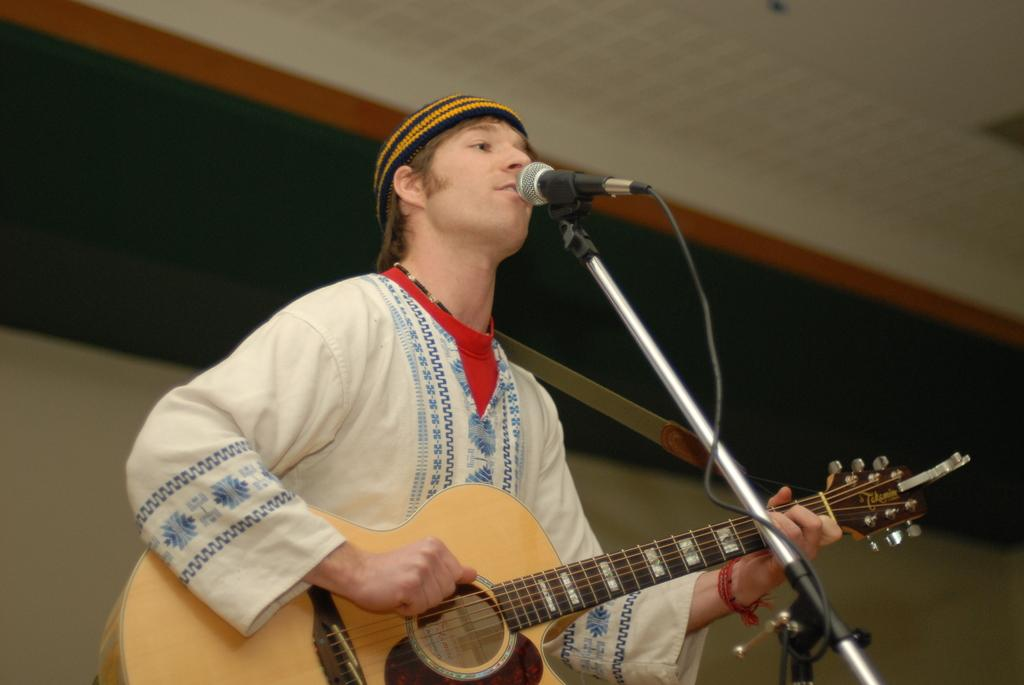What is the person in the image doing? The person is holding a guitar and singing. What object is the person using to amplify their voice? There is a microphone with a stand in the image. What type of mark can be seen on the person's grandmother's notebook in the image? There is no mention of a grandmother or a notebook in the image, so it is not possible to answer that question. 